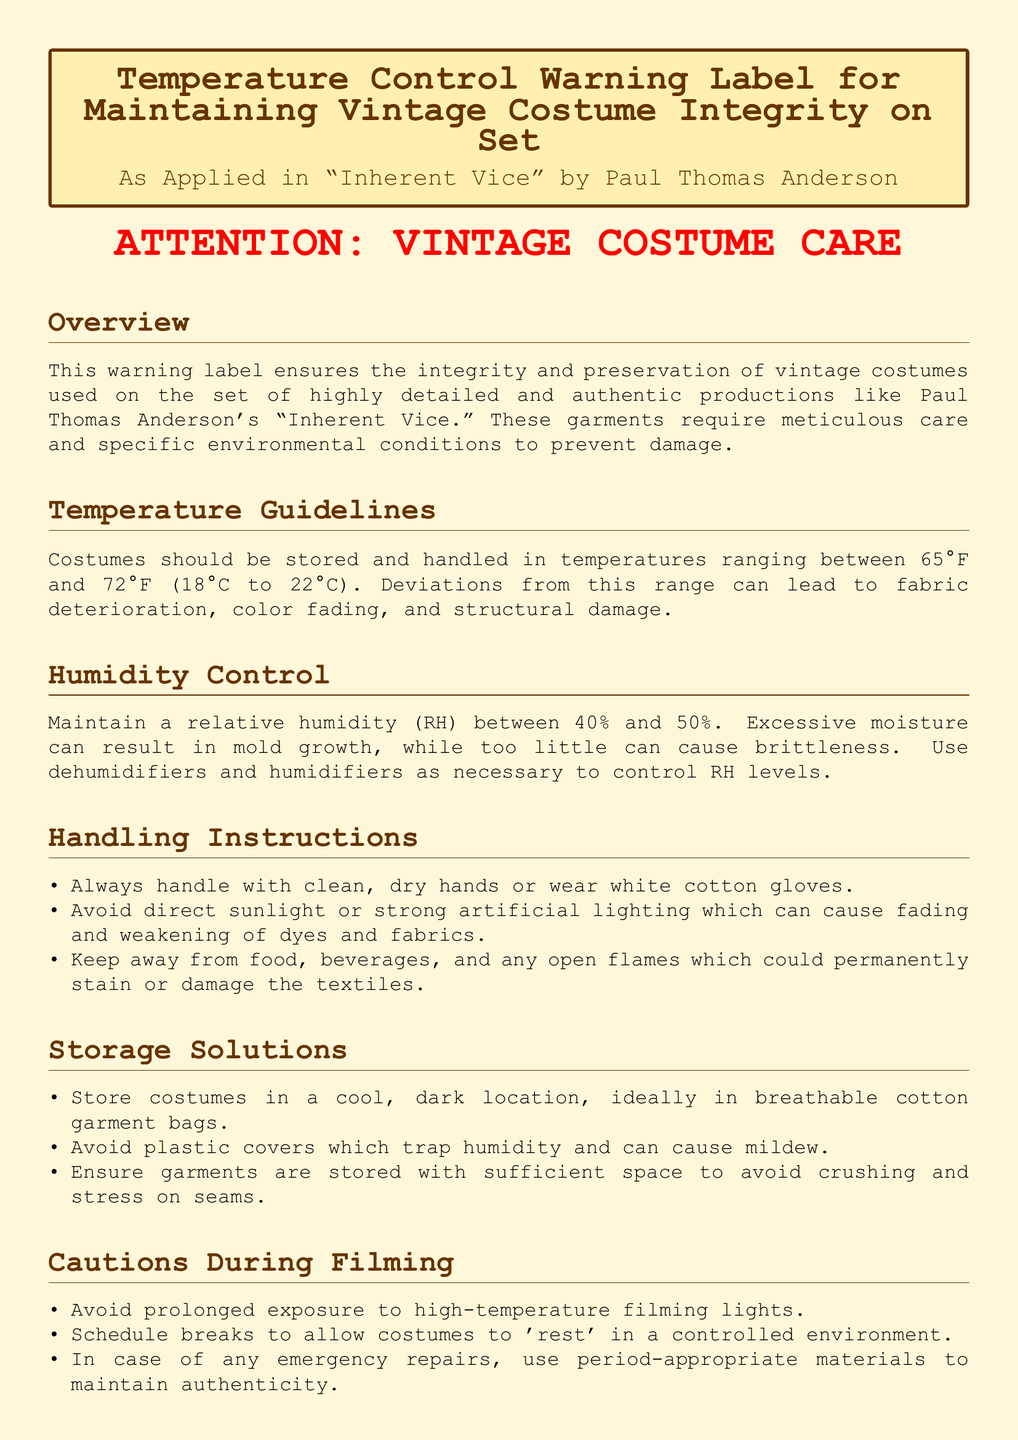What is the temperature range for storing costumes? The temperature range for storing costumes is specified in the guidelines as between 65°F and 72°F (18°C to 22°C).
Answer: 65°F to 72°F What relative humidity should be maintained? The document states that a relative humidity between 40% and 50% should be maintained.
Answer: 40% to 50% What should be avoided during handling? The document indicates that direct sunlight or strong artificial lighting should be avoided during handling.
Answer: Direct sunlight What is recommended for costume storage? The document suggests storing costumes in breathable cotton garment bags and in a cool, dark location.
Answer: Cotton garment bags How often should inspections be conducted? The inspection frequency is specified as weekly to check for signs of wear or environmental damage.
Answer: Weekly What is the general disclaimer about failing to adhere to guidelines? The disclaimer mentions that failure to adhere may result in irreversible damage to the vintage costumes.
Answer: Irreversible damage What kind of gloves should be used when handling costumes? The handling instructions specify wearing white cotton gloves when handling costumes.
Answer: White cotton gloves What should be used to remove dust from costumes? The maintenance section states that a soft brush should be used to remove dust particles from costumes.
Answer: Soft brush 